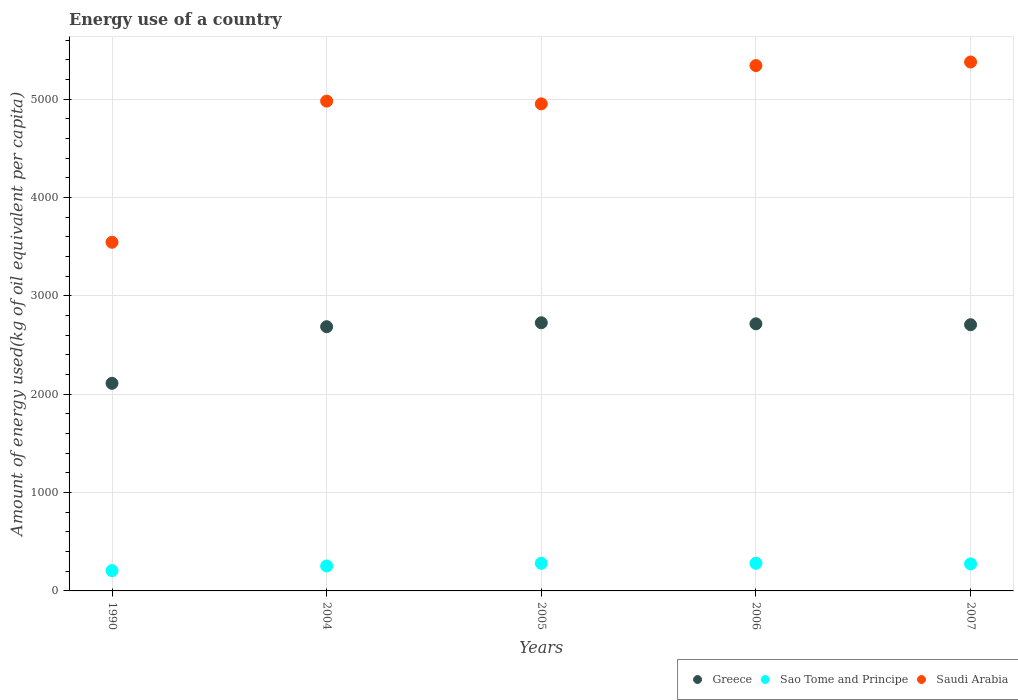How many different coloured dotlines are there?
Provide a short and direct response. 3. Is the number of dotlines equal to the number of legend labels?
Provide a succinct answer. Yes. What is the amount of energy used in in Saudi Arabia in 2004?
Your response must be concise. 4980.31. Across all years, what is the maximum amount of energy used in in Sao Tome and Principe?
Make the answer very short. 281. Across all years, what is the minimum amount of energy used in in Saudi Arabia?
Provide a succinct answer. 3545.24. What is the total amount of energy used in in Greece in the graph?
Make the answer very short. 1.29e+04. What is the difference between the amount of energy used in in Saudi Arabia in 2004 and that in 2007?
Keep it short and to the point. -397.74. What is the difference between the amount of energy used in in Sao Tome and Principe in 2006 and the amount of energy used in in Saudi Arabia in 1990?
Your answer should be very brief. -3264.24. What is the average amount of energy used in in Greece per year?
Offer a very short reply. 2589.38. In the year 2004, what is the difference between the amount of energy used in in Saudi Arabia and amount of energy used in in Sao Tome and Principe?
Offer a very short reply. 4726.53. In how many years, is the amount of energy used in in Sao Tome and Principe greater than 1400 kg?
Make the answer very short. 0. What is the ratio of the amount of energy used in in Greece in 2004 to that in 2005?
Ensure brevity in your answer.  0.99. Is the amount of energy used in in Greece in 2004 less than that in 2005?
Your answer should be compact. Yes. Is the difference between the amount of energy used in in Saudi Arabia in 2004 and 2005 greater than the difference between the amount of energy used in in Sao Tome and Principe in 2004 and 2005?
Your response must be concise. Yes. What is the difference between the highest and the second highest amount of energy used in in Saudi Arabia?
Your answer should be compact. 36.23. What is the difference between the highest and the lowest amount of energy used in in Sao Tome and Principe?
Provide a succinct answer. 74.48. In how many years, is the amount of energy used in in Greece greater than the average amount of energy used in in Greece taken over all years?
Your answer should be compact. 4. Is the sum of the amount of energy used in in Greece in 2005 and 2006 greater than the maximum amount of energy used in in Sao Tome and Principe across all years?
Make the answer very short. Yes. Is it the case that in every year, the sum of the amount of energy used in in Sao Tome and Principe and amount of energy used in in Greece  is greater than the amount of energy used in in Saudi Arabia?
Your response must be concise. No. Does the amount of energy used in in Greece monotonically increase over the years?
Keep it short and to the point. No. Is the amount of energy used in in Saudi Arabia strictly greater than the amount of energy used in in Greece over the years?
Give a very brief answer. Yes. Is the amount of energy used in in Saudi Arabia strictly less than the amount of energy used in in Greece over the years?
Ensure brevity in your answer.  No. How many dotlines are there?
Your answer should be compact. 3. How many years are there in the graph?
Ensure brevity in your answer.  5. What is the difference between two consecutive major ticks on the Y-axis?
Provide a succinct answer. 1000. Does the graph contain grids?
Provide a short and direct response. Yes. Where does the legend appear in the graph?
Give a very brief answer. Bottom right. How many legend labels are there?
Give a very brief answer. 3. How are the legend labels stacked?
Offer a terse response. Horizontal. What is the title of the graph?
Ensure brevity in your answer.  Energy use of a country. What is the label or title of the X-axis?
Offer a very short reply. Years. What is the label or title of the Y-axis?
Offer a terse response. Amount of energy used(kg of oil equivalent per capita). What is the Amount of energy used(kg of oil equivalent per capita) in Greece in 1990?
Your answer should be very brief. 2110.94. What is the Amount of energy used(kg of oil equivalent per capita) of Sao Tome and Principe in 1990?
Offer a very short reply. 206.52. What is the Amount of energy used(kg of oil equivalent per capita) of Saudi Arabia in 1990?
Offer a terse response. 3545.24. What is the Amount of energy used(kg of oil equivalent per capita) of Greece in 2004?
Offer a very short reply. 2686.52. What is the Amount of energy used(kg of oil equivalent per capita) of Sao Tome and Principe in 2004?
Your answer should be compact. 253.79. What is the Amount of energy used(kg of oil equivalent per capita) in Saudi Arabia in 2004?
Your answer should be very brief. 4980.31. What is the Amount of energy used(kg of oil equivalent per capita) of Greece in 2005?
Your response must be concise. 2726.67. What is the Amount of energy used(kg of oil equivalent per capita) of Sao Tome and Principe in 2005?
Keep it short and to the point. 280.78. What is the Amount of energy used(kg of oil equivalent per capita) of Saudi Arabia in 2005?
Ensure brevity in your answer.  4952.56. What is the Amount of energy used(kg of oil equivalent per capita) of Greece in 2006?
Your answer should be very brief. 2715.93. What is the Amount of energy used(kg of oil equivalent per capita) in Sao Tome and Principe in 2006?
Offer a terse response. 281. What is the Amount of energy used(kg of oil equivalent per capita) of Saudi Arabia in 2006?
Your answer should be very brief. 5341.83. What is the Amount of energy used(kg of oil equivalent per capita) of Greece in 2007?
Make the answer very short. 2706.86. What is the Amount of energy used(kg of oil equivalent per capita) in Sao Tome and Principe in 2007?
Offer a terse response. 274.89. What is the Amount of energy used(kg of oil equivalent per capita) in Saudi Arabia in 2007?
Your answer should be very brief. 5378.06. Across all years, what is the maximum Amount of energy used(kg of oil equivalent per capita) of Greece?
Make the answer very short. 2726.67. Across all years, what is the maximum Amount of energy used(kg of oil equivalent per capita) in Sao Tome and Principe?
Your response must be concise. 281. Across all years, what is the maximum Amount of energy used(kg of oil equivalent per capita) in Saudi Arabia?
Your answer should be compact. 5378.06. Across all years, what is the minimum Amount of energy used(kg of oil equivalent per capita) in Greece?
Your answer should be compact. 2110.94. Across all years, what is the minimum Amount of energy used(kg of oil equivalent per capita) of Sao Tome and Principe?
Make the answer very short. 206.52. Across all years, what is the minimum Amount of energy used(kg of oil equivalent per capita) of Saudi Arabia?
Your answer should be compact. 3545.24. What is the total Amount of energy used(kg of oil equivalent per capita) of Greece in the graph?
Your answer should be compact. 1.29e+04. What is the total Amount of energy used(kg of oil equivalent per capita) of Sao Tome and Principe in the graph?
Your answer should be very brief. 1296.98. What is the total Amount of energy used(kg of oil equivalent per capita) in Saudi Arabia in the graph?
Offer a terse response. 2.42e+04. What is the difference between the Amount of energy used(kg of oil equivalent per capita) of Greece in 1990 and that in 2004?
Your answer should be very brief. -575.58. What is the difference between the Amount of energy used(kg of oil equivalent per capita) in Sao Tome and Principe in 1990 and that in 2004?
Your answer should be compact. -47.27. What is the difference between the Amount of energy used(kg of oil equivalent per capita) in Saudi Arabia in 1990 and that in 2004?
Ensure brevity in your answer.  -1435.07. What is the difference between the Amount of energy used(kg of oil equivalent per capita) in Greece in 1990 and that in 2005?
Your answer should be very brief. -615.73. What is the difference between the Amount of energy used(kg of oil equivalent per capita) in Sao Tome and Principe in 1990 and that in 2005?
Give a very brief answer. -74.26. What is the difference between the Amount of energy used(kg of oil equivalent per capita) in Saudi Arabia in 1990 and that in 2005?
Give a very brief answer. -1407.32. What is the difference between the Amount of energy used(kg of oil equivalent per capita) in Greece in 1990 and that in 2006?
Your answer should be compact. -604.99. What is the difference between the Amount of energy used(kg of oil equivalent per capita) in Sao Tome and Principe in 1990 and that in 2006?
Keep it short and to the point. -74.48. What is the difference between the Amount of energy used(kg of oil equivalent per capita) in Saudi Arabia in 1990 and that in 2006?
Make the answer very short. -1796.59. What is the difference between the Amount of energy used(kg of oil equivalent per capita) in Greece in 1990 and that in 2007?
Provide a succinct answer. -595.92. What is the difference between the Amount of energy used(kg of oil equivalent per capita) in Sao Tome and Principe in 1990 and that in 2007?
Make the answer very short. -68.37. What is the difference between the Amount of energy used(kg of oil equivalent per capita) of Saudi Arabia in 1990 and that in 2007?
Offer a terse response. -1832.81. What is the difference between the Amount of energy used(kg of oil equivalent per capita) in Greece in 2004 and that in 2005?
Your answer should be very brief. -40.15. What is the difference between the Amount of energy used(kg of oil equivalent per capita) in Sao Tome and Principe in 2004 and that in 2005?
Provide a short and direct response. -26.99. What is the difference between the Amount of energy used(kg of oil equivalent per capita) of Saudi Arabia in 2004 and that in 2005?
Your answer should be compact. 27.75. What is the difference between the Amount of energy used(kg of oil equivalent per capita) of Greece in 2004 and that in 2006?
Your response must be concise. -29.41. What is the difference between the Amount of energy used(kg of oil equivalent per capita) of Sao Tome and Principe in 2004 and that in 2006?
Ensure brevity in your answer.  -27.21. What is the difference between the Amount of energy used(kg of oil equivalent per capita) in Saudi Arabia in 2004 and that in 2006?
Your answer should be very brief. -361.52. What is the difference between the Amount of energy used(kg of oil equivalent per capita) of Greece in 2004 and that in 2007?
Make the answer very short. -20.34. What is the difference between the Amount of energy used(kg of oil equivalent per capita) of Sao Tome and Principe in 2004 and that in 2007?
Provide a succinct answer. -21.1. What is the difference between the Amount of energy used(kg of oil equivalent per capita) of Saudi Arabia in 2004 and that in 2007?
Make the answer very short. -397.74. What is the difference between the Amount of energy used(kg of oil equivalent per capita) in Greece in 2005 and that in 2006?
Your answer should be compact. 10.74. What is the difference between the Amount of energy used(kg of oil equivalent per capita) of Sao Tome and Principe in 2005 and that in 2006?
Offer a terse response. -0.22. What is the difference between the Amount of energy used(kg of oil equivalent per capita) in Saudi Arabia in 2005 and that in 2006?
Provide a succinct answer. -389.27. What is the difference between the Amount of energy used(kg of oil equivalent per capita) of Greece in 2005 and that in 2007?
Ensure brevity in your answer.  19.81. What is the difference between the Amount of energy used(kg of oil equivalent per capita) in Sao Tome and Principe in 2005 and that in 2007?
Ensure brevity in your answer.  5.89. What is the difference between the Amount of energy used(kg of oil equivalent per capita) in Saudi Arabia in 2005 and that in 2007?
Provide a succinct answer. -425.5. What is the difference between the Amount of energy used(kg of oil equivalent per capita) of Greece in 2006 and that in 2007?
Your answer should be compact. 9.07. What is the difference between the Amount of energy used(kg of oil equivalent per capita) of Sao Tome and Principe in 2006 and that in 2007?
Your answer should be very brief. 6.11. What is the difference between the Amount of energy used(kg of oil equivalent per capita) in Saudi Arabia in 2006 and that in 2007?
Make the answer very short. -36.23. What is the difference between the Amount of energy used(kg of oil equivalent per capita) of Greece in 1990 and the Amount of energy used(kg of oil equivalent per capita) of Sao Tome and Principe in 2004?
Your answer should be very brief. 1857.15. What is the difference between the Amount of energy used(kg of oil equivalent per capita) of Greece in 1990 and the Amount of energy used(kg of oil equivalent per capita) of Saudi Arabia in 2004?
Provide a short and direct response. -2869.38. What is the difference between the Amount of energy used(kg of oil equivalent per capita) of Sao Tome and Principe in 1990 and the Amount of energy used(kg of oil equivalent per capita) of Saudi Arabia in 2004?
Keep it short and to the point. -4773.79. What is the difference between the Amount of energy used(kg of oil equivalent per capita) in Greece in 1990 and the Amount of energy used(kg of oil equivalent per capita) in Sao Tome and Principe in 2005?
Offer a terse response. 1830.16. What is the difference between the Amount of energy used(kg of oil equivalent per capita) of Greece in 1990 and the Amount of energy used(kg of oil equivalent per capita) of Saudi Arabia in 2005?
Your answer should be compact. -2841.63. What is the difference between the Amount of energy used(kg of oil equivalent per capita) in Sao Tome and Principe in 1990 and the Amount of energy used(kg of oil equivalent per capita) in Saudi Arabia in 2005?
Ensure brevity in your answer.  -4746.04. What is the difference between the Amount of energy used(kg of oil equivalent per capita) in Greece in 1990 and the Amount of energy used(kg of oil equivalent per capita) in Sao Tome and Principe in 2006?
Make the answer very short. 1829.94. What is the difference between the Amount of energy used(kg of oil equivalent per capita) of Greece in 1990 and the Amount of energy used(kg of oil equivalent per capita) of Saudi Arabia in 2006?
Your answer should be compact. -3230.89. What is the difference between the Amount of energy used(kg of oil equivalent per capita) in Sao Tome and Principe in 1990 and the Amount of energy used(kg of oil equivalent per capita) in Saudi Arabia in 2006?
Your answer should be very brief. -5135.31. What is the difference between the Amount of energy used(kg of oil equivalent per capita) in Greece in 1990 and the Amount of energy used(kg of oil equivalent per capita) in Sao Tome and Principe in 2007?
Provide a succinct answer. 1836.05. What is the difference between the Amount of energy used(kg of oil equivalent per capita) in Greece in 1990 and the Amount of energy used(kg of oil equivalent per capita) in Saudi Arabia in 2007?
Provide a short and direct response. -3267.12. What is the difference between the Amount of energy used(kg of oil equivalent per capita) in Sao Tome and Principe in 1990 and the Amount of energy used(kg of oil equivalent per capita) in Saudi Arabia in 2007?
Offer a terse response. -5171.54. What is the difference between the Amount of energy used(kg of oil equivalent per capita) of Greece in 2004 and the Amount of energy used(kg of oil equivalent per capita) of Sao Tome and Principe in 2005?
Offer a very short reply. 2405.74. What is the difference between the Amount of energy used(kg of oil equivalent per capita) in Greece in 2004 and the Amount of energy used(kg of oil equivalent per capita) in Saudi Arabia in 2005?
Your answer should be compact. -2266.04. What is the difference between the Amount of energy used(kg of oil equivalent per capita) of Sao Tome and Principe in 2004 and the Amount of energy used(kg of oil equivalent per capita) of Saudi Arabia in 2005?
Give a very brief answer. -4698.77. What is the difference between the Amount of energy used(kg of oil equivalent per capita) of Greece in 2004 and the Amount of energy used(kg of oil equivalent per capita) of Sao Tome and Principe in 2006?
Provide a succinct answer. 2405.52. What is the difference between the Amount of energy used(kg of oil equivalent per capita) in Greece in 2004 and the Amount of energy used(kg of oil equivalent per capita) in Saudi Arabia in 2006?
Your answer should be very brief. -2655.31. What is the difference between the Amount of energy used(kg of oil equivalent per capita) in Sao Tome and Principe in 2004 and the Amount of energy used(kg of oil equivalent per capita) in Saudi Arabia in 2006?
Your answer should be very brief. -5088.04. What is the difference between the Amount of energy used(kg of oil equivalent per capita) of Greece in 2004 and the Amount of energy used(kg of oil equivalent per capita) of Sao Tome and Principe in 2007?
Make the answer very short. 2411.63. What is the difference between the Amount of energy used(kg of oil equivalent per capita) of Greece in 2004 and the Amount of energy used(kg of oil equivalent per capita) of Saudi Arabia in 2007?
Offer a very short reply. -2691.54. What is the difference between the Amount of energy used(kg of oil equivalent per capita) in Sao Tome and Principe in 2004 and the Amount of energy used(kg of oil equivalent per capita) in Saudi Arabia in 2007?
Make the answer very short. -5124.27. What is the difference between the Amount of energy used(kg of oil equivalent per capita) in Greece in 2005 and the Amount of energy used(kg of oil equivalent per capita) in Sao Tome and Principe in 2006?
Keep it short and to the point. 2445.67. What is the difference between the Amount of energy used(kg of oil equivalent per capita) in Greece in 2005 and the Amount of energy used(kg of oil equivalent per capita) in Saudi Arabia in 2006?
Your answer should be very brief. -2615.16. What is the difference between the Amount of energy used(kg of oil equivalent per capita) in Sao Tome and Principe in 2005 and the Amount of energy used(kg of oil equivalent per capita) in Saudi Arabia in 2006?
Keep it short and to the point. -5061.05. What is the difference between the Amount of energy used(kg of oil equivalent per capita) of Greece in 2005 and the Amount of energy used(kg of oil equivalent per capita) of Sao Tome and Principe in 2007?
Your answer should be compact. 2451.78. What is the difference between the Amount of energy used(kg of oil equivalent per capita) in Greece in 2005 and the Amount of energy used(kg of oil equivalent per capita) in Saudi Arabia in 2007?
Your answer should be very brief. -2651.39. What is the difference between the Amount of energy used(kg of oil equivalent per capita) in Sao Tome and Principe in 2005 and the Amount of energy used(kg of oil equivalent per capita) in Saudi Arabia in 2007?
Your answer should be compact. -5097.28. What is the difference between the Amount of energy used(kg of oil equivalent per capita) in Greece in 2006 and the Amount of energy used(kg of oil equivalent per capita) in Sao Tome and Principe in 2007?
Your answer should be compact. 2441.04. What is the difference between the Amount of energy used(kg of oil equivalent per capita) in Greece in 2006 and the Amount of energy used(kg of oil equivalent per capita) in Saudi Arabia in 2007?
Make the answer very short. -2662.13. What is the difference between the Amount of energy used(kg of oil equivalent per capita) of Sao Tome and Principe in 2006 and the Amount of energy used(kg of oil equivalent per capita) of Saudi Arabia in 2007?
Provide a succinct answer. -5097.06. What is the average Amount of energy used(kg of oil equivalent per capita) in Greece per year?
Provide a short and direct response. 2589.38. What is the average Amount of energy used(kg of oil equivalent per capita) of Sao Tome and Principe per year?
Give a very brief answer. 259.39. What is the average Amount of energy used(kg of oil equivalent per capita) in Saudi Arabia per year?
Offer a very short reply. 4839.6. In the year 1990, what is the difference between the Amount of energy used(kg of oil equivalent per capita) of Greece and Amount of energy used(kg of oil equivalent per capita) of Sao Tome and Principe?
Ensure brevity in your answer.  1904.41. In the year 1990, what is the difference between the Amount of energy used(kg of oil equivalent per capita) in Greece and Amount of energy used(kg of oil equivalent per capita) in Saudi Arabia?
Offer a terse response. -1434.31. In the year 1990, what is the difference between the Amount of energy used(kg of oil equivalent per capita) of Sao Tome and Principe and Amount of energy used(kg of oil equivalent per capita) of Saudi Arabia?
Provide a succinct answer. -3338.72. In the year 2004, what is the difference between the Amount of energy used(kg of oil equivalent per capita) in Greece and Amount of energy used(kg of oil equivalent per capita) in Sao Tome and Principe?
Your answer should be compact. 2432.73. In the year 2004, what is the difference between the Amount of energy used(kg of oil equivalent per capita) in Greece and Amount of energy used(kg of oil equivalent per capita) in Saudi Arabia?
Your answer should be compact. -2293.79. In the year 2004, what is the difference between the Amount of energy used(kg of oil equivalent per capita) of Sao Tome and Principe and Amount of energy used(kg of oil equivalent per capita) of Saudi Arabia?
Make the answer very short. -4726.53. In the year 2005, what is the difference between the Amount of energy used(kg of oil equivalent per capita) in Greece and Amount of energy used(kg of oil equivalent per capita) in Sao Tome and Principe?
Provide a succinct answer. 2445.89. In the year 2005, what is the difference between the Amount of energy used(kg of oil equivalent per capita) in Greece and Amount of energy used(kg of oil equivalent per capita) in Saudi Arabia?
Your answer should be very brief. -2225.89. In the year 2005, what is the difference between the Amount of energy used(kg of oil equivalent per capita) in Sao Tome and Principe and Amount of energy used(kg of oil equivalent per capita) in Saudi Arabia?
Provide a short and direct response. -4671.78. In the year 2006, what is the difference between the Amount of energy used(kg of oil equivalent per capita) in Greece and Amount of energy used(kg of oil equivalent per capita) in Sao Tome and Principe?
Keep it short and to the point. 2434.93. In the year 2006, what is the difference between the Amount of energy used(kg of oil equivalent per capita) in Greece and Amount of energy used(kg of oil equivalent per capita) in Saudi Arabia?
Provide a succinct answer. -2625.9. In the year 2006, what is the difference between the Amount of energy used(kg of oil equivalent per capita) of Sao Tome and Principe and Amount of energy used(kg of oil equivalent per capita) of Saudi Arabia?
Keep it short and to the point. -5060.83. In the year 2007, what is the difference between the Amount of energy used(kg of oil equivalent per capita) of Greece and Amount of energy used(kg of oil equivalent per capita) of Sao Tome and Principe?
Offer a terse response. 2431.97. In the year 2007, what is the difference between the Amount of energy used(kg of oil equivalent per capita) in Greece and Amount of energy used(kg of oil equivalent per capita) in Saudi Arabia?
Offer a very short reply. -2671.2. In the year 2007, what is the difference between the Amount of energy used(kg of oil equivalent per capita) of Sao Tome and Principe and Amount of energy used(kg of oil equivalent per capita) of Saudi Arabia?
Ensure brevity in your answer.  -5103.17. What is the ratio of the Amount of energy used(kg of oil equivalent per capita) of Greece in 1990 to that in 2004?
Offer a very short reply. 0.79. What is the ratio of the Amount of energy used(kg of oil equivalent per capita) in Sao Tome and Principe in 1990 to that in 2004?
Your answer should be very brief. 0.81. What is the ratio of the Amount of energy used(kg of oil equivalent per capita) of Saudi Arabia in 1990 to that in 2004?
Offer a very short reply. 0.71. What is the ratio of the Amount of energy used(kg of oil equivalent per capita) in Greece in 1990 to that in 2005?
Your answer should be compact. 0.77. What is the ratio of the Amount of energy used(kg of oil equivalent per capita) in Sao Tome and Principe in 1990 to that in 2005?
Your answer should be compact. 0.74. What is the ratio of the Amount of energy used(kg of oil equivalent per capita) of Saudi Arabia in 1990 to that in 2005?
Make the answer very short. 0.72. What is the ratio of the Amount of energy used(kg of oil equivalent per capita) of Greece in 1990 to that in 2006?
Provide a succinct answer. 0.78. What is the ratio of the Amount of energy used(kg of oil equivalent per capita) of Sao Tome and Principe in 1990 to that in 2006?
Provide a short and direct response. 0.73. What is the ratio of the Amount of energy used(kg of oil equivalent per capita) in Saudi Arabia in 1990 to that in 2006?
Offer a terse response. 0.66. What is the ratio of the Amount of energy used(kg of oil equivalent per capita) in Greece in 1990 to that in 2007?
Your answer should be compact. 0.78. What is the ratio of the Amount of energy used(kg of oil equivalent per capita) of Sao Tome and Principe in 1990 to that in 2007?
Provide a succinct answer. 0.75. What is the ratio of the Amount of energy used(kg of oil equivalent per capita) of Saudi Arabia in 1990 to that in 2007?
Your answer should be very brief. 0.66. What is the ratio of the Amount of energy used(kg of oil equivalent per capita) in Sao Tome and Principe in 2004 to that in 2005?
Ensure brevity in your answer.  0.9. What is the ratio of the Amount of energy used(kg of oil equivalent per capita) in Saudi Arabia in 2004 to that in 2005?
Make the answer very short. 1.01. What is the ratio of the Amount of energy used(kg of oil equivalent per capita) in Sao Tome and Principe in 2004 to that in 2006?
Make the answer very short. 0.9. What is the ratio of the Amount of energy used(kg of oil equivalent per capita) in Saudi Arabia in 2004 to that in 2006?
Offer a terse response. 0.93. What is the ratio of the Amount of energy used(kg of oil equivalent per capita) of Sao Tome and Principe in 2004 to that in 2007?
Provide a short and direct response. 0.92. What is the ratio of the Amount of energy used(kg of oil equivalent per capita) in Saudi Arabia in 2004 to that in 2007?
Keep it short and to the point. 0.93. What is the ratio of the Amount of energy used(kg of oil equivalent per capita) of Saudi Arabia in 2005 to that in 2006?
Offer a very short reply. 0.93. What is the ratio of the Amount of energy used(kg of oil equivalent per capita) in Greece in 2005 to that in 2007?
Your response must be concise. 1.01. What is the ratio of the Amount of energy used(kg of oil equivalent per capita) in Sao Tome and Principe in 2005 to that in 2007?
Provide a short and direct response. 1.02. What is the ratio of the Amount of energy used(kg of oil equivalent per capita) in Saudi Arabia in 2005 to that in 2007?
Give a very brief answer. 0.92. What is the ratio of the Amount of energy used(kg of oil equivalent per capita) in Greece in 2006 to that in 2007?
Your response must be concise. 1. What is the ratio of the Amount of energy used(kg of oil equivalent per capita) of Sao Tome and Principe in 2006 to that in 2007?
Keep it short and to the point. 1.02. What is the ratio of the Amount of energy used(kg of oil equivalent per capita) of Saudi Arabia in 2006 to that in 2007?
Offer a very short reply. 0.99. What is the difference between the highest and the second highest Amount of energy used(kg of oil equivalent per capita) in Greece?
Your answer should be very brief. 10.74. What is the difference between the highest and the second highest Amount of energy used(kg of oil equivalent per capita) in Sao Tome and Principe?
Your response must be concise. 0.22. What is the difference between the highest and the second highest Amount of energy used(kg of oil equivalent per capita) of Saudi Arabia?
Your answer should be very brief. 36.23. What is the difference between the highest and the lowest Amount of energy used(kg of oil equivalent per capita) of Greece?
Make the answer very short. 615.73. What is the difference between the highest and the lowest Amount of energy used(kg of oil equivalent per capita) of Sao Tome and Principe?
Provide a short and direct response. 74.48. What is the difference between the highest and the lowest Amount of energy used(kg of oil equivalent per capita) in Saudi Arabia?
Give a very brief answer. 1832.81. 